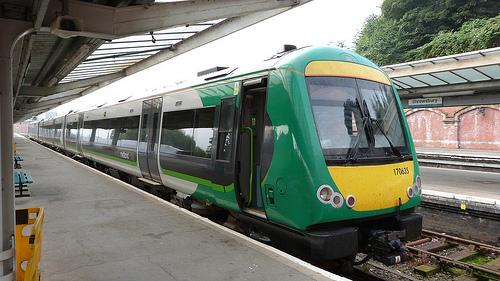Write a concise summary of the image focusing on the main mode of transportation present. The image depicts a vibrant train at a station with various distinct features such as benches, signs, and lights. Provide a detailed description of the image, focusing on the structures surrounding the main object. A colorful train is at a station with rusted tracks, blue benches on the platform, a green and white sign, and a roof with trees overhead. Provide a brief description of the dominant elements in the image. A green, yellow, and white commuter train is at a station with blue benches, rusted tracks, and a green and white sign. Write a brief storyline inspired by the elements present in the image. The colorful train silently rolled into the deserted station, adorned with blue benches and a green and white sign, offering a momentary respite for weary travelers. Narrate the scene depicted in the image in a poetic manner. Amidst rusted tracks, the verdant and golden train awaits, while weary travelers rest upon blue benches and light shines from above. In a few words, mention the central theme of the image. Commuter train at a station. Mention the most significant object in the image along with its color and location. A green, yellow, and white commuter train dominates the image, located on elevated boarding platforms. Describe the key aspects of the image in a single sentence. A colorful train rests at the station with blue benches, a green and white sign, and lights around it. Describe the primary components of the image using descriptive adjectives. A vivid green, yellow, and white commuter train is stationed amidst blue benches, illuminated lights, and a rustic setting. Imagine you are a journalist and provide a headline for the image. "Colorful Commuter Train Arrives at Station with Distinctive Features and Surroundings" 